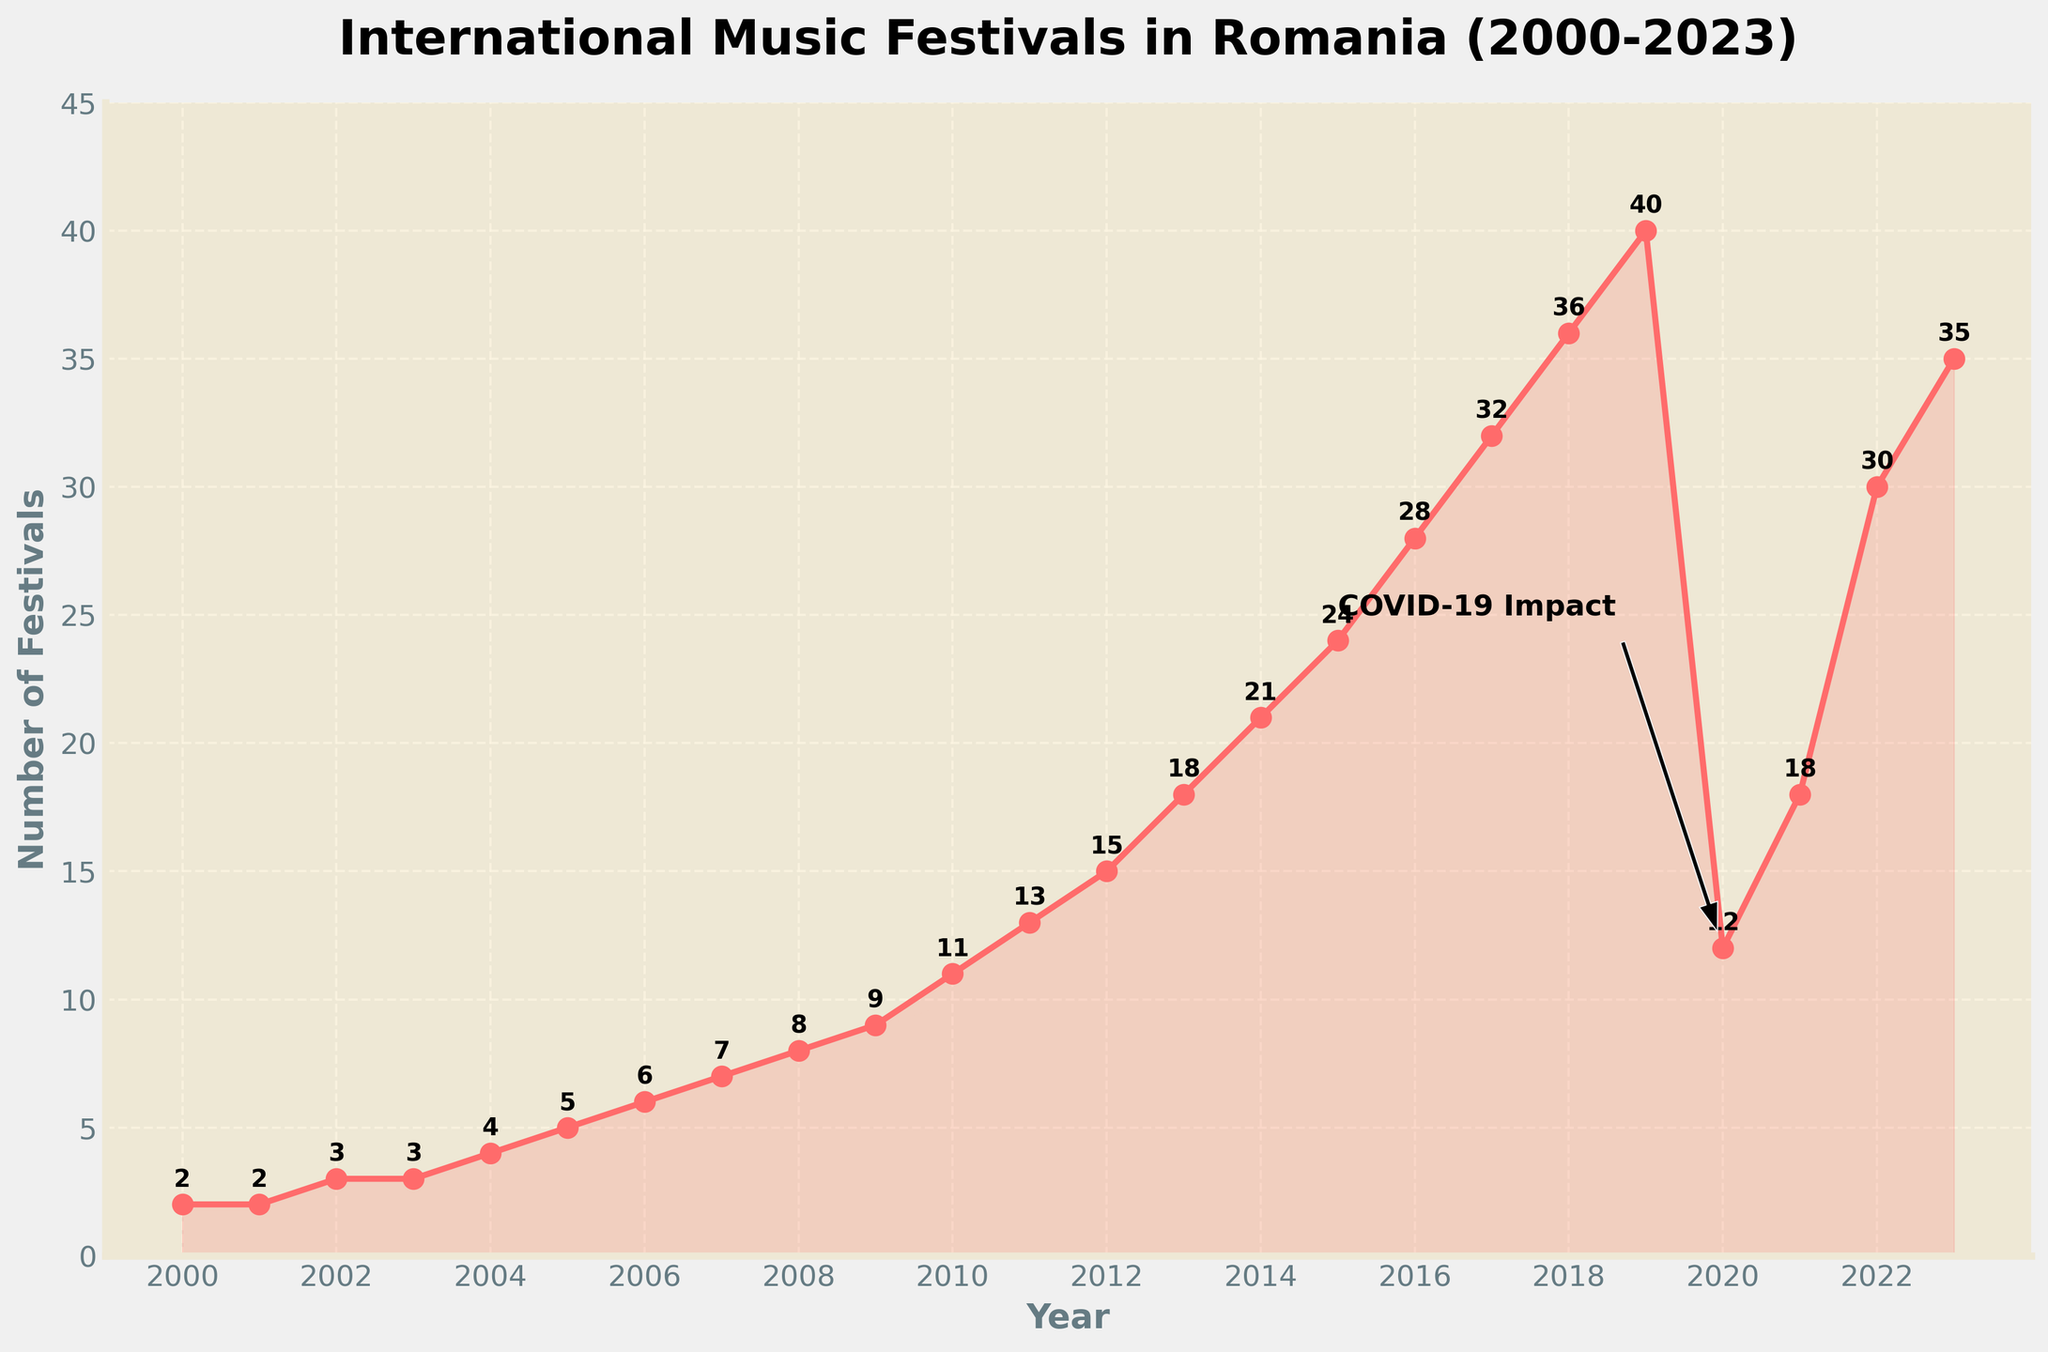How did the number of international music festivals change from 2000 to 2010? Start from 2000 with 2 festivals and look at the value in 2010, which is 11 festivals. The increase is from 2 to 11.
Answer: Increased from 2 to 11 What is the largest increase in the number of festivals in a single year? Compare the increase between each consecutive year. The largest increase is from 2019 to 2020, where the number of festivals decreased by 28.
Answer: 28 How did the number of festivals change in 2020 compared to 2019? The number of festivals in 2019 is 40, and in 2020 it dropped to 12.
Answer: Decreased from 40 to 12 What was the trend in the number of festivals from 2016 to 2019? The trend shows an increase from 28 in 2016, to 32 in 2017, to 36 in 2018, and then to 40 in 2019.
Answer: Increasing Which year experienced the highest number of festivals? Check the data points for the maximum value, which is 40 festivals in 2019.
Answer: 2019 Did the number of festivals ever decline and then rise again within the timeline? In 2020, the number of festivals dropped to 12 due to the COVID-19 pandemic and rose again to 35 by 2023.
Answer: Yes What is the visual indicator used to highlight the impact of COVID-19 on the number of festivals? There is an annotation with an arrow pointing to the year 2020 and a text label saying "COVID-19 Impact."
Answer: Annotation with arrow Comparing 2004 and 2009, how many more festivals were held in 2009? Subtract the number of festivals in 2004 (4 festivals) from the number in 2009 (9 festivals). 9 - 4 = 5.
Answer: 5 more What is the average number of festivals held annually from 2000 to 2023? Sum all the values and divide by the number of years (24). (2+2+3+3+4+5+6+7+8+9+11+13+15+18+21+24+28+32+36+40+12+18+30+35)=388. Average = 388/24 ≈ 16.17
Answer: 16.17 How did the number of festivals in 2022 compare to 2018? In 2018, there were 36 festivals, and in 2022, there were 30 festivals.
Answer: Decreased from 36 to 30 